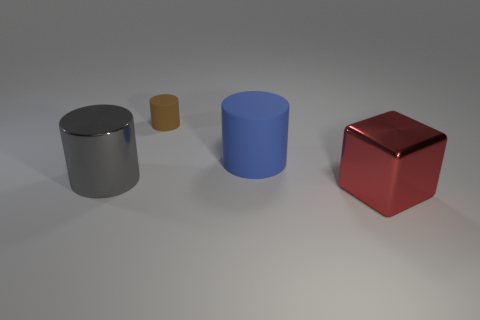What number of things are either big objects that are behind the gray metal object or objects that are behind the big cube?
Your answer should be compact. 3. There is a big gray thing that is the same shape as the brown rubber thing; what is its material?
Ensure brevity in your answer.  Metal. What number of objects are either big blue things that are on the left side of the red metallic block or tiny matte cylinders?
Make the answer very short. 2. There is another thing that is the same material as the big gray object; what is its shape?
Keep it short and to the point. Cube. What number of gray shiny objects are the same shape as the large blue thing?
Your answer should be compact. 1. What is the material of the small brown thing?
Keep it short and to the point. Rubber. What number of cylinders are either tiny red matte things or big objects?
Make the answer very short. 2. There is a rubber cylinder that is on the left side of the large matte cylinder; what is its color?
Your answer should be compact. Brown. What number of shiny blocks are the same size as the red metallic object?
Your response must be concise. 0. There is a large object that is behind the gray shiny thing; does it have the same shape as the large gray thing on the left side of the tiny rubber thing?
Make the answer very short. Yes. 